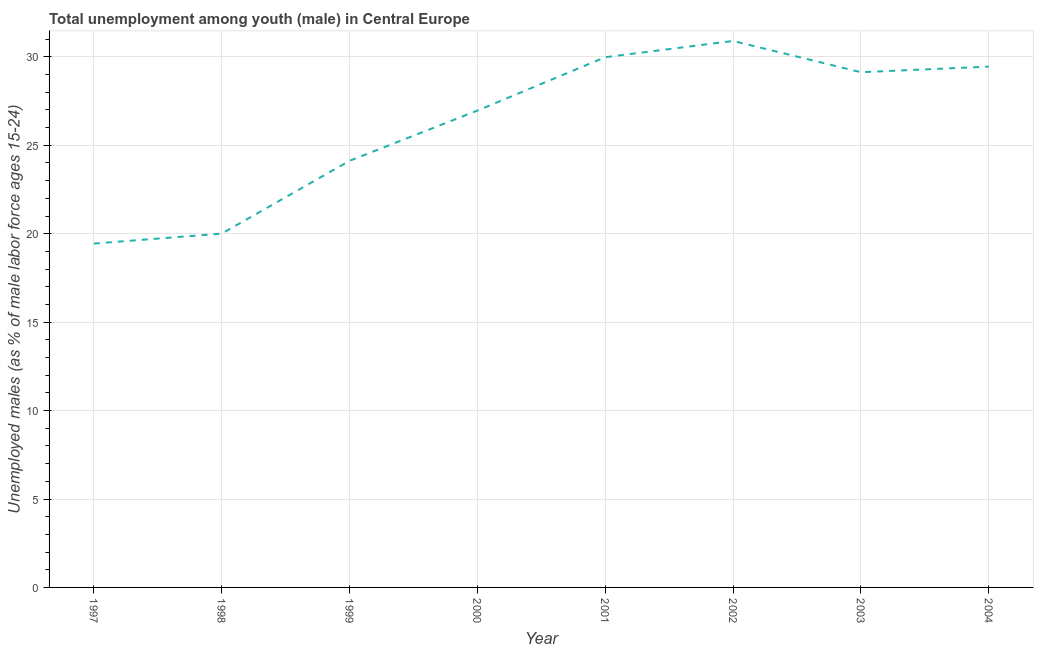What is the unemployed male youth population in 1998?
Provide a short and direct response. 20.01. Across all years, what is the maximum unemployed male youth population?
Provide a short and direct response. 30.9. Across all years, what is the minimum unemployed male youth population?
Provide a short and direct response. 19.44. In which year was the unemployed male youth population maximum?
Provide a succinct answer. 2002. What is the sum of the unemployed male youth population?
Offer a terse response. 210. What is the difference between the unemployed male youth population in 1999 and 2002?
Ensure brevity in your answer.  -6.78. What is the average unemployed male youth population per year?
Keep it short and to the point. 26.25. What is the median unemployed male youth population?
Provide a short and direct response. 28.05. Do a majority of the years between 1997 and 2002 (inclusive) have unemployed male youth population greater than 28 %?
Make the answer very short. No. What is the ratio of the unemployed male youth population in 1999 to that in 2004?
Make the answer very short. 0.82. Is the difference between the unemployed male youth population in 1998 and 2002 greater than the difference between any two years?
Offer a terse response. No. What is the difference between the highest and the second highest unemployed male youth population?
Provide a short and direct response. 0.92. What is the difference between the highest and the lowest unemployed male youth population?
Offer a terse response. 11.46. How many lines are there?
Your answer should be compact. 1. How many years are there in the graph?
Provide a short and direct response. 8. What is the difference between two consecutive major ticks on the Y-axis?
Offer a very short reply. 5. Does the graph contain grids?
Offer a terse response. Yes. What is the title of the graph?
Make the answer very short. Total unemployment among youth (male) in Central Europe. What is the label or title of the X-axis?
Provide a succinct answer. Year. What is the label or title of the Y-axis?
Provide a succinct answer. Unemployed males (as % of male labor force ages 15-24). What is the Unemployed males (as % of male labor force ages 15-24) in 1997?
Your response must be concise. 19.44. What is the Unemployed males (as % of male labor force ages 15-24) of 1998?
Offer a very short reply. 20.01. What is the Unemployed males (as % of male labor force ages 15-24) in 1999?
Provide a short and direct response. 24.12. What is the Unemployed males (as % of male labor force ages 15-24) of 2000?
Keep it short and to the point. 26.96. What is the Unemployed males (as % of male labor force ages 15-24) of 2001?
Offer a terse response. 29.98. What is the Unemployed males (as % of male labor force ages 15-24) of 2002?
Ensure brevity in your answer.  30.9. What is the Unemployed males (as % of male labor force ages 15-24) in 2003?
Make the answer very short. 29.13. What is the Unemployed males (as % of male labor force ages 15-24) in 2004?
Your answer should be compact. 29.45. What is the difference between the Unemployed males (as % of male labor force ages 15-24) in 1997 and 1998?
Offer a terse response. -0.56. What is the difference between the Unemployed males (as % of male labor force ages 15-24) in 1997 and 1999?
Keep it short and to the point. -4.68. What is the difference between the Unemployed males (as % of male labor force ages 15-24) in 1997 and 2000?
Provide a short and direct response. -7.52. What is the difference between the Unemployed males (as % of male labor force ages 15-24) in 1997 and 2001?
Your response must be concise. -10.54. What is the difference between the Unemployed males (as % of male labor force ages 15-24) in 1997 and 2002?
Give a very brief answer. -11.46. What is the difference between the Unemployed males (as % of male labor force ages 15-24) in 1997 and 2003?
Your answer should be compact. -9.69. What is the difference between the Unemployed males (as % of male labor force ages 15-24) in 1997 and 2004?
Provide a succinct answer. -10.01. What is the difference between the Unemployed males (as % of male labor force ages 15-24) in 1998 and 1999?
Your answer should be compact. -4.12. What is the difference between the Unemployed males (as % of male labor force ages 15-24) in 1998 and 2000?
Provide a short and direct response. -6.96. What is the difference between the Unemployed males (as % of male labor force ages 15-24) in 1998 and 2001?
Give a very brief answer. -9.98. What is the difference between the Unemployed males (as % of male labor force ages 15-24) in 1998 and 2002?
Your answer should be compact. -10.89. What is the difference between the Unemployed males (as % of male labor force ages 15-24) in 1998 and 2003?
Your answer should be very brief. -9.13. What is the difference between the Unemployed males (as % of male labor force ages 15-24) in 1998 and 2004?
Ensure brevity in your answer.  -9.44. What is the difference between the Unemployed males (as % of male labor force ages 15-24) in 1999 and 2000?
Give a very brief answer. -2.84. What is the difference between the Unemployed males (as % of male labor force ages 15-24) in 1999 and 2001?
Make the answer very short. -5.86. What is the difference between the Unemployed males (as % of male labor force ages 15-24) in 1999 and 2002?
Ensure brevity in your answer.  -6.78. What is the difference between the Unemployed males (as % of male labor force ages 15-24) in 1999 and 2003?
Provide a short and direct response. -5.01. What is the difference between the Unemployed males (as % of male labor force ages 15-24) in 1999 and 2004?
Keep it short and to the point. -5.33. What is the difference between the Unemployed males (as % of male labor force ages 15-24) in 2000 and 2001?
Provide a short and direct response. -3.02. What is the difference between the Unemployed males (as % of male labor force ages 15-24) in 2000 and 2002?
Your answer should be compact. -3.94. What is the difference between the Unemployed males (as % of male labor force ages 15-24) in 2000 and 2003?
Your answer should be very brief. -2.17. What is the difference between the Unemployed males (as % of male labor force ages 15-24) in 2000 and 2004?
Your response must be concise. -2.49. What is the difference between the Unemployed males (as % of male labor force ages 15-24) in 2001 and 2002?
Give a very brief answer. -0.92. What is the difference between the Unemployed males (as % of male labor force ages 15-24) in 2001 and 2003?
Provide a succinct answer. 0.85. What is the difference between the Unemployed males (as % of male labor force ages 15-24) in 2001 and 2004?
Make the answer very short. 0.53. What is the difference between the Unemployed males (as % of male labor force ages 15-24) in 2002 and 2003?
Provide a short and direct response. 1.77. What is the difference between the Unemployed males (as % of male labor force ages 15-24) in 2002 and 2004?
Your response must be concise. 1.45. What is the difference between the Unemployed males (as % of male labor force ages 15-24) in 2003 and 2004?
Make the answer very short. -0.32. What is the ratio of the Unemployed males (as % of male labor force ages 15-24) in 1997 to that in 1999?
Keep it short and to the point. 0.81. What is the ratio of the Unemployed males (as % of male labor force ages 15-24) in 1997 to that in 2000?
Make the answer very short. 0.72. What is the ratio of the Unemployed males (as % of male labor force ages 15-24) in 1997 to that in 2001?
Your answer should be compact. 0.65. What is the ratio of the Unemployed males (as % of male labor force ages 15-24) in 1997 to that in 2002?
Give a very brief answer. 0.63. What is the ratio of the Unemployed males (as % of male labor force ages 15-24) in 1997 to that in 2003?
Keep it short and to the point. 0.67. What is the ratio of the Unemployed males (as % of male labor force ages 15-24) in 1997 to that in 2004?
Your answer should be compact. 0.66. What is the ratio of the Unemployed males (as % of male labor force ages 15-24) in 1998 to that in 1999?
Provide a succinct answer. 0.83. What is the ratio of the Unemployed males (as % of male labor force ages 15-24) in 1998 to that in 2000?
Offer a terse response. 0.74. What is the ratio of the Unemployed males (as % of male labor force ages 15-24) in 1998 to that in 2001?
Ensure brevity in your answer.  0.67. What is the ratio of the Unemployed males (as % of male labor force ages 15-24) in 1998 to that in 2002?
Provide a succinct answer. 0.65. What is the ratio of the Unemployed males (as % of male labor force ages 15-24) in 1998 to that in 2003?
Your response must be concise. 0.69. What is the ratio of the Unemployed males (as % of male labor force ages 15-24) in 1998 to that in 2004?
Keep it short and to the point. 0.68. What is the ratio of the Unemployed males (as % of male labor force ages 15-24) in 1999 to that in 2000?
Ensure brevity in your answer.  0.9. What is the ratio of the Unemployed males (as % of male labor force ages 15-24) in 1999 to that in 2001?
Your response must be concise. 0.81. What is the ratio of the Unemployed males (as % of male labor force ages 15-24) in 1999 to that in 2002?
Your answer should be compact. 0.78. What is the ratio of the Unemployed males (as % of male labor force ages 15-24) in 1999 to that in 2003?
Offer a very short reply. 0.83. What is the ratio of the Unemployed males (as % of male labor force ages 15-24) in 1999 to that in 2004?
Offer a very short reply. 0.82. What is the ratio of the Unemployed males (as % of male labor force ages 15-24) in 2000 to that in 2001?
Your response must be concise. 0.9. What is the ratio of the Unemployed males (as % of male labor force ages 15-24) in 2000 to that in 2002?
Your response must be concise. 0.87. What is the ratio of the Unemployed males (as % of male labor force ages 15-24) in 2000 to that in 2003?
Make the answer very short. 0.93. What is the ratio of the Unemployed males (as % of male labor force ages 15-24) in 2000 to that in 2004?
Keep it short and to the point. 0.92. What is the ratio of the Unemployed males (as % of male labor force ages 15-24) in 2001 to that in 2004?
Make the answer very short. 1.02. What is the ratio of the Unemployed males (as % of male labor force ages 15-24) in 2002 to that in 2003?
Offer a terse response. 1.06. What is the ratio of the Unemployed males (as % of male labor force ages 15-24) in 2002 to that in 2004?
Offer a very short reply. 1.05. 